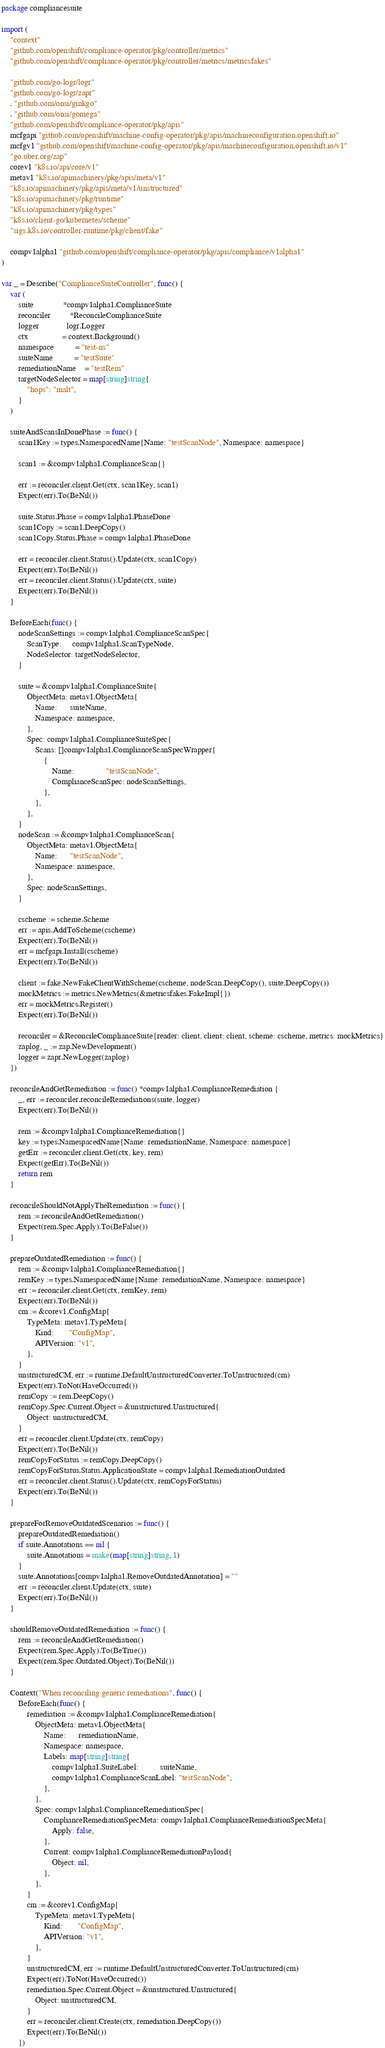Convert code to text. <code><loc_0><loc_0><loc_500><loc_500><_Go_>package compliancesuite

import (
	"context"
	"github.com/openshift/compliance-operator/pkg/controller/metrics"
	"github.com/openshift/compliance-operator/pkg/controller/metrics/metricsfakes"

	"github.com/go-logr/logr"
	"github.com/go-logr/zapr"
	. "github.com/onsi/ginkgo"
	. "github.com/onsi/gomega"
	"github.com/openshift/compliance-operator/pkg/apis"
	mcfgapi "github.com/openshift/machine-config-operator/pkg/apis/machineconfiguration.openshift.io"
	mcfgv1 "github.com/openshift/machine-config-operator/pkg/apis/machineconfiguration.openshift.io/v1"
	"go.uber.org/zap"
	corev1 "k8s.io/api/core/v1"
	metav1 "k8s.io/apimachinery/pkg/apis/meta/v1"
	"k8s.io/apimachinery/pkg/apis/meta/v1/unstructured"
	"k8s.io/apimachinery/pkg/runtime"
	"k8s.io/apimachinery/pkg/types"
	"k8s.io/client-go/kubernetes/scheme"
	"sigs.k8s.io/controller-runtime/pkg/client/fake"

	compv1alpha1 "github.com/openshift/compliance-operator/pkg/apis/compliance/v1alpha1"
)

var _ = Describe("ComplianceSuiteController", func() {
	var (
		suite              *compv1alpha1.ComplianceSuite
		reconciler         *ReconcileComplianceSuite
		logger             logr.Logger
		ctx                = context.Background()
		namespace          = "test-ns"
		suiteName          = "testSuite"
		remediationName    = "testRem"
		targetNodeSelector = map[string]string{
			"hops": "malt",
		}
	)

	suiteAndScansInDonePhase := func() {
		scan1Key := types.NamespacedName{Name: "testScanNode", Namespace: namespace}

		scan1 := &compv1alpha1.ComplianceScan{}

		err := reconciler.client.Get(ctx, scan1Key, scan1)
		Expect(err).To(BeNil())

		suite.Status.Phase = compv1alpha1.PhaseDone
		scan1Copy := scan1.DeepCopy()
		scan1Copy.Status.Phase = compv1alpha1.PhaseDone

		err = reconciler.client.Status().Update(ctx, scan1Copy)
		Expect(err).To(BeNil())
		err = reconciler.client.Status().Update(ctx, suite)
		Expect(err).To(BeNil())
	}

	BeforeEach(func() {
		nodeScanSettings := compv1alpha1.ComplianceScanSpec{
			ScanType:     compv1alpha1.ScanTypeNode,
			NodeSelector: targetNodeSelector,
		}

		suite = &compv1alpha1.ComplianceSuite{
			ObjectMeta: metav1.ObjectMeta{
				Name:      suiteName,
				Namespace: namespace,
			},
			Spec: compv1alpha1.ComplianceSuiteSpec{
				Scans: []compv1alpha1.ComplianceScanSpecWrapper{
					{
						Name:               "testScanNode",
						ComplianceScanSpec: nodeScanSettings,
					},
				},
			},
		}
		nodeScan := &compv1alpha1.ComplianceScan{
			ObjectMeta: metav1.ObjectMeta{
				Name:      "testScanNode",
				Namespace: namespace,
			},
			Spec: nodeScanSettings,
		}

		cscheme := scheme.Scheme
		err := apis.AddToScheme(cscheme)
		Expect(err).To(BeNil())
		err = mcfgapi.Install(cscheme)
		Expect(err).To(BeNil())

		client := fake.NewFakeClientWithScheme(cscheme, nodeScan.DeepCopy(), suite.DeepCopy())
		mockMetrics := metrics.NewMetrics(&metricsfakes.FakeImpl{})
		err = mockMetrics.Register()
		Expect(err).To(BeNil())

		reconciler = &ReconcileComplianceSuite{reader: client, client: client, scheme: cscheme, metrics: mockMetrics}
		zaplog, _ := zap.NewDevelopment()
		logger = zapr.NewLogger(zaplog)
	})

	reconcileAndGetRemediation := func() *compv1alpha1.ComplianceRemediation {
		_, err := reconciler.reconcileRemediations(suite, logger)
		Expect(err).To(BeNil())

		rem := &compv1alpha1.ComplianceRemediation{}
		key := types.NamespacedName{Name: remediationName, Namespace: namespace}
		getErr := reconciler.client.Get(ctx, key, rem)
		Expect(getErr).To(BeNil())
		return rem
	}

	reconcileShouldNotApplyTheRemediation := func() {
		rem := reconcileAndGetRemediation()
		Expect(rem.Spec.Apply).To(BeFalse())
	}

	prepareOutdatedRemediation := func() {
		rem := &compv1alpha1.ComplianceRemediation{}
		remKey := types.NamespacedName{Name: remediationName, Namespace: namespace}
		err := reconciler.client.Get(ctx, remKey, rem)
		Expect(err).To(BeNil())
		cm := &corev1.ConfigMap{
			TypeMeta: metav1.TypeMeta{
				Kind:       "ConfigMap",
				APIVersion: "v1",
			},
		}
		unstructuredCM, err := runtime.DefaultUnstructuredConverter.ToUnstructured(cm)
		Expect(err).ToNot(HaveOccurred())
		remCopy := rem.DeepCopy()
		remCopy.Spec.Current.Object = &unstructured.Unstructured{
			Object: unstructuredCM,
		}
		err = reconciler.client.Update(ctx, remCopy)
		Expect(err).To(BeNil())
		remCopyForStatus := remCopy.DeepCopy()
		remCopyForStatus.Status.ApplicationState = compv1alpha1.RemediationOutdated
		err = reconciler.client.Status().Update(ctx, remCopyForStatus)
		Expect(err).To(BeNil())
	}

	prepareForRemoveOutdatedScenarios := func() {
		prepareOutdatedRemediation()
		if suite.Annotations == nil {
			suite.Annotations = make(map[string]string, 1)
		}
		suite.Annotations[compv1alpha1.RemoveOutdatedAnnotation] = ""
		err := reconciler.client.Update(ctx, suite)
		Expect(err).To(BeNil())
	}

	shouldRemoveOutdatedRemediation := func() {
		rem := reconcileAndGetRemediation()
		Expect(rem.Spec.Apply).To(BeTrue())
		Expect(rem.Spec.Outdated.Object).To(BeNil())
	}

	Context("When reconciling generic remediations", func() {
		BeforeEach(func() {
			remediation := &compv1alpha1.ComplianceRemediation{
				ObjectMeta: metav1.ObjectMeta{
					Name:      remediationName,
					Namespace: namespace,
					Labels: map[string]string{
						compv1alpha1.SuiteLabel:          suiteName,
						compv1alpha1.ComplianceScanLabel: "testScanNode",
					},
				},
				Spec: compv1alpha1.ComplianceRemediationSpec{
					ComplianceRemediationSpecMeta: compv1alpha1.ComplianceRemediationSpecMeta{
						Apply: false,
					},
					Current: compv1alpha1.ComplianceRemediationPayload{
						Object: nil,
					},
				},
			}
			cm := &corev1.ConfigMap{
				TypeMeta: metav1.TypeMeta{
					Kind:       "ConfigMap",
					APIVersion: "v1",
				},
			}
			unstructuredCM, err := runtime.DefaultUnstructuredConverter.ToUnstructured(cm)
			Expect(err).ToNot(HaveOccurred())
			remediation.Spec.Current.Object = &unstructured.Unstructured{
				Object: unstructuredCM,
			}
			err = reconciler.client.Create(ctx, remediation.DeepCopy())
			Expect(err).To(BeNil())
		})
</code> 